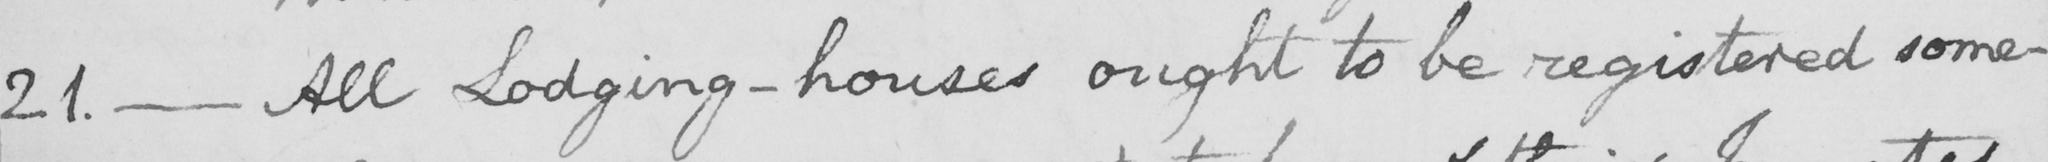What does this handwritten line say? 21 .  _  All Lodging-houses ought to be registered some- 